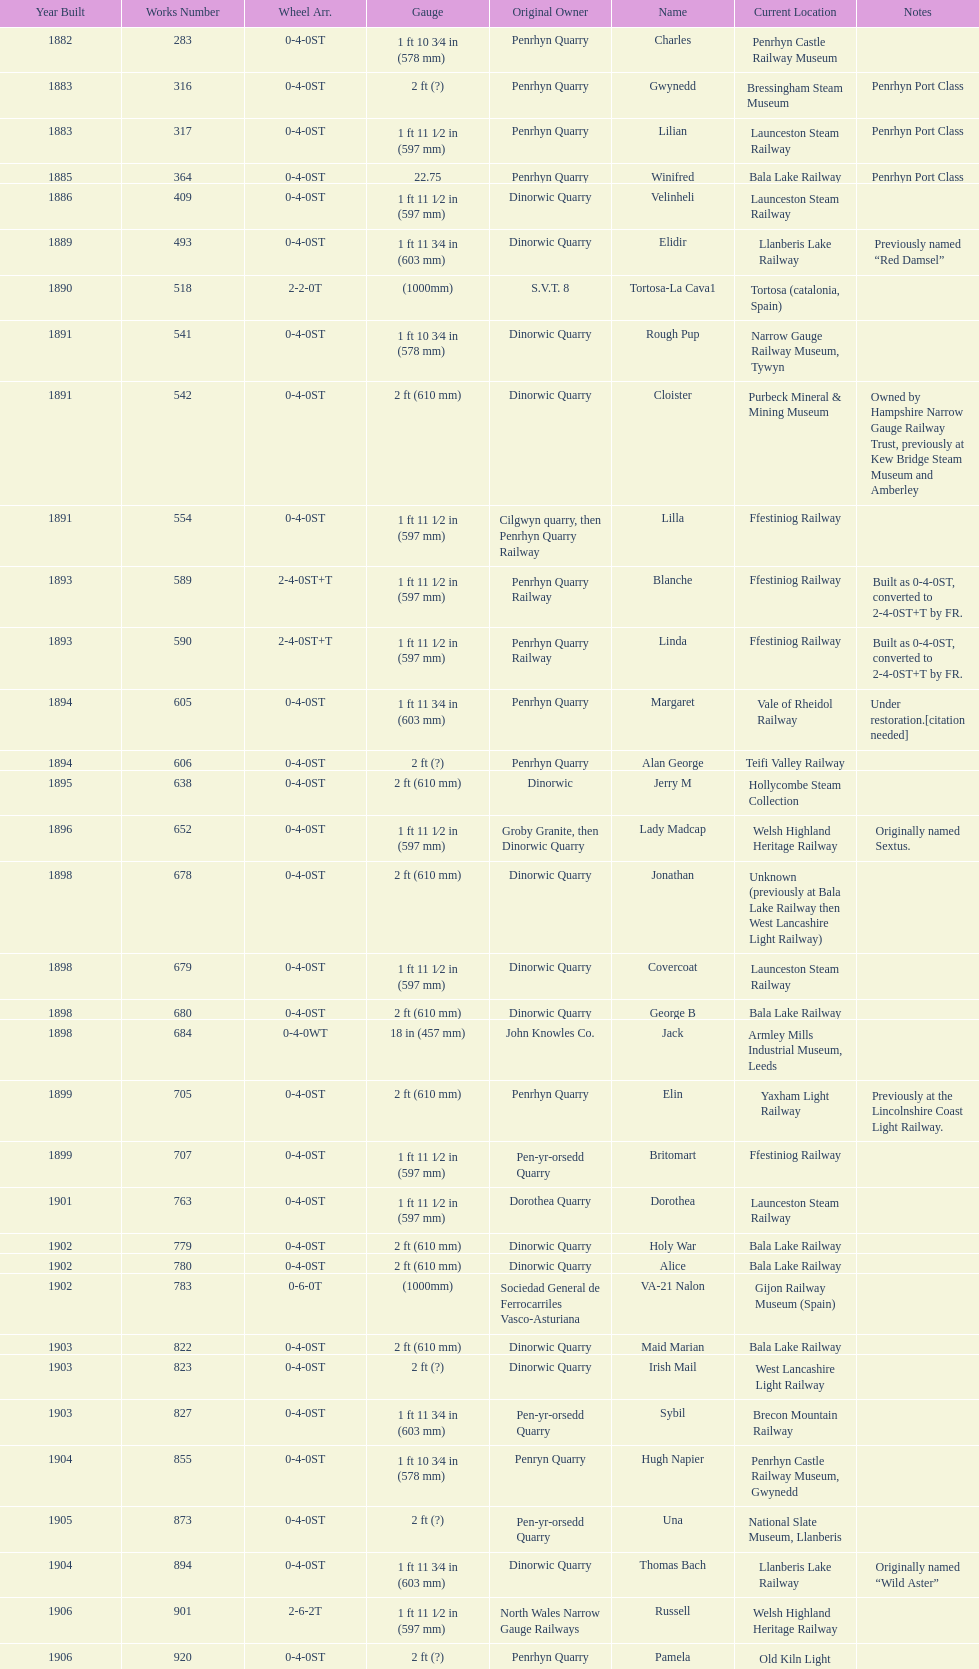In what year were the highest number of steam locomotives constructed? 1898. 